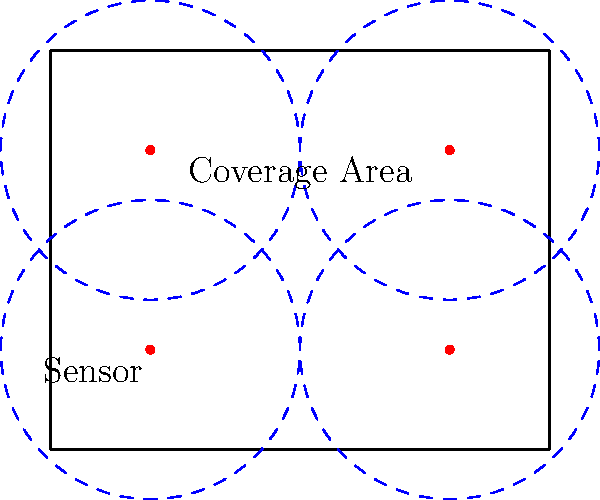In a building's security system layout, sensors are placed to maximize coverage while minimizing the number of devices. Given a rectangular building with dimensions 10m x 8m, and sensors with a circular detection range of 3m radius, what is the minimum number of sensors required to ensure complete coverage of the building's interior? To solve this problem, we'll follow these steps:

1. Analyze the building dimensions:
   - Length = 10m
   - Width = 8m

2. Consider the sensor coverage:
   - Radius of detection = 3m
   - Diameter of detection = 6m

3. Calculate the number of sensors needed along the length:
   - 10m ÷ 6m = 1.67
   - Round up to 2 sensors

4. Calculate the number of sensors needed along the width:
   - 8m ÷ 6m = 1.33
   - Round up to 2 sensors

5. Determine the total number of sensors:
   - Total sensors = sensors along length × sensors along width
   - Total sensors = 2 × 2 = 4

6. Verify coverage:
   - Place sensors at coordinates (2,2), (8,2), (2,6), and (8,6)
   - This arrangement ensures complete coverage with minimal overlap

Therefore, the minimum number of sensors required to ensure complete coverage of the building's interior is 4.
Answer: 4 sensors 